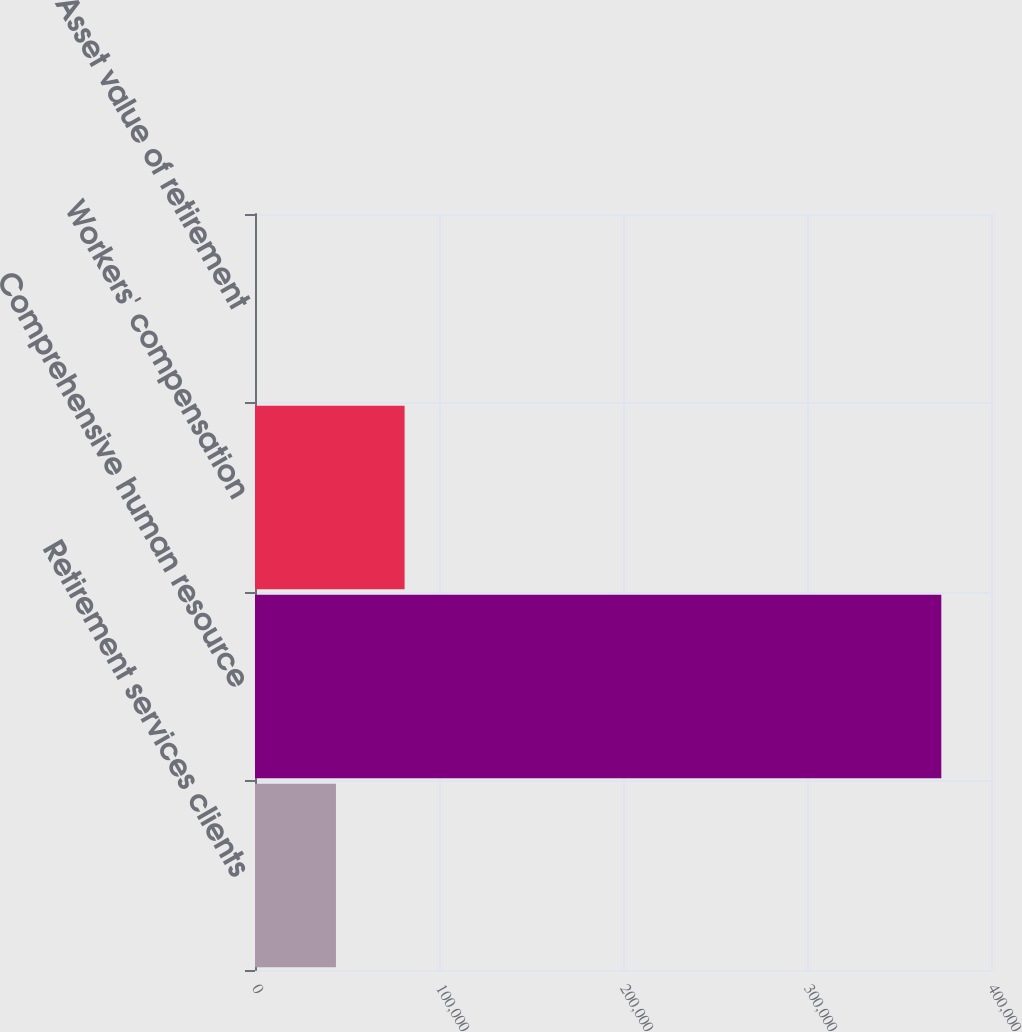Convert chart. <chart><loc_0><loc_0><loc_500><loc_500><bar_chart><fcel>Retirement services clients<fcel>Comprehensive human resource<fcel>Workers' compensation<fcel>Asset value of retirement<nl><fcel>44000<fcel>373000<fcel>81299.1<fcel>8.7<nl></chart> 